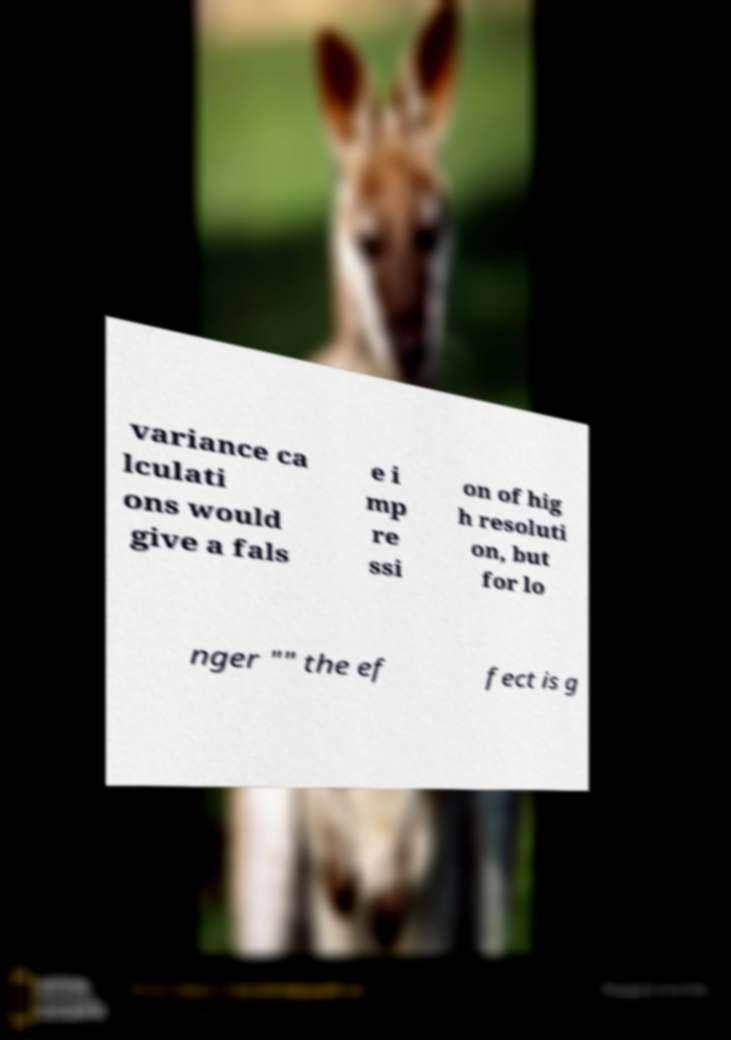Could you assist in decoding the text presented in this image and type it out clearly? variance ca lculati ons would give a fals e i mp re ssi on of hig h resoluti on, but for lo nger "" the ef fect is g 